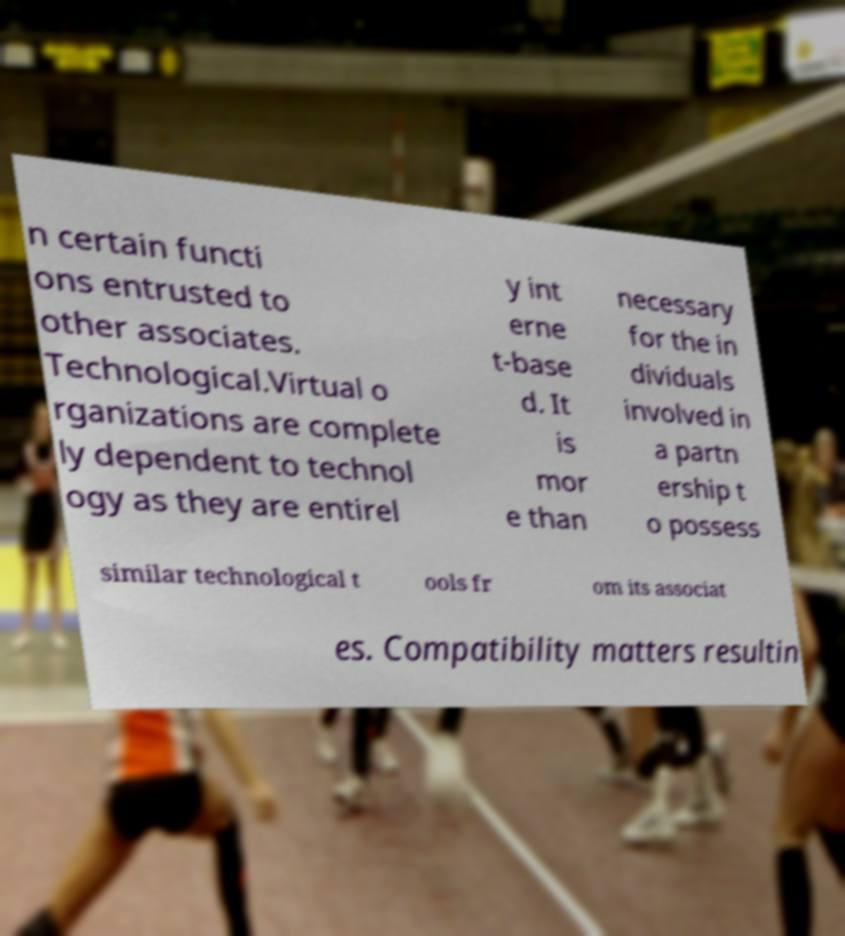For documentation purposes, I need the text within this image transcribed. Could you provide that? n certain functi ons entrusted to other associates. Technological.Virtual o rganizations are complete ly dependent to technol ogy as they are entirel y int erne t-base d. It is mor e than necessary for the in dividuals involved in a partn ership t o possess similar technological t ools fr om its associat es. Compatibility matters resultin 